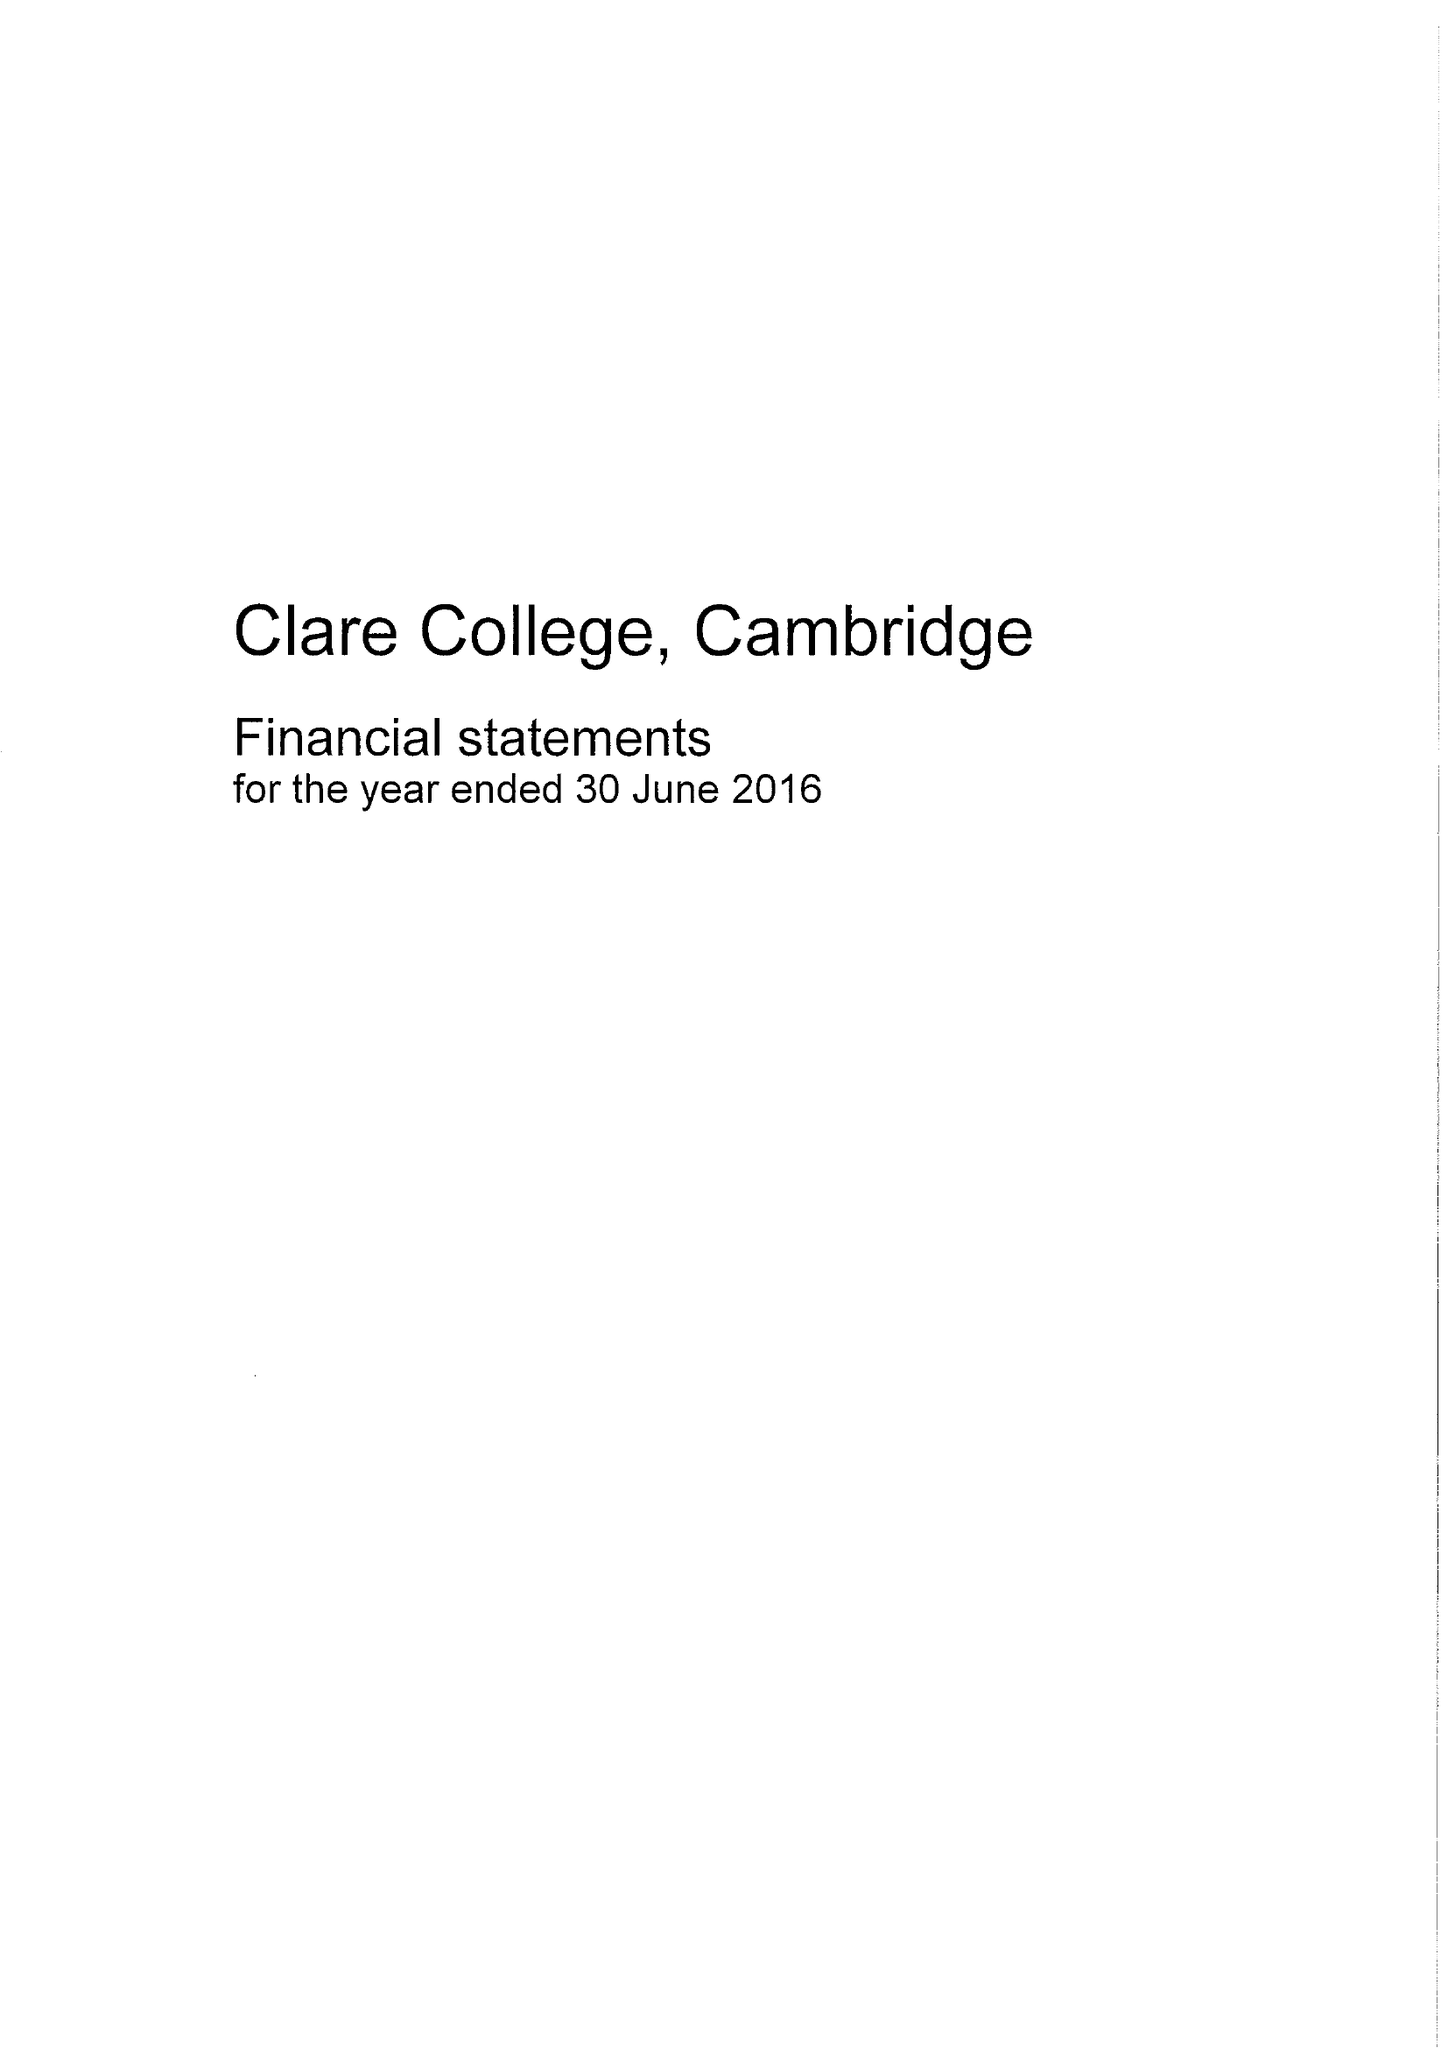What is the value for the charity_number?
Answer the question using a single word or phrase. 1137531 